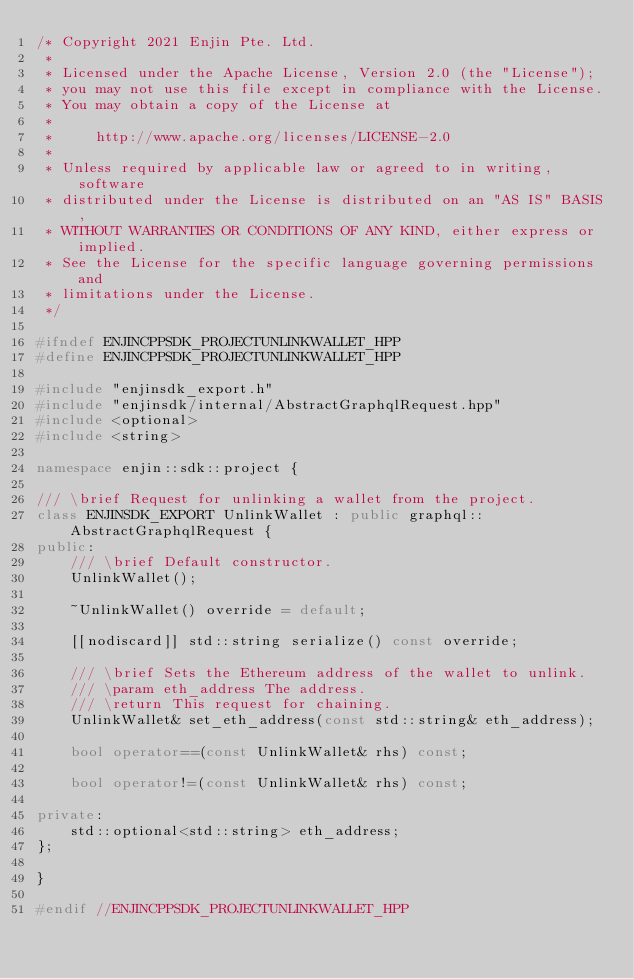Convert code to text. <code><loc_0><loc_0><loc_500><loc_500><_C++_>/* Copyright 2021 Enjin Pte. Ltd.
 *
 * Licensed under the Apache License, Version 2.0 (the "License");
 * you may not use this file except in compliance with the License.
 * You may obtain a copy of the License at
 *
 *     http://www.apache.org/licenses/LICENSE-2.0
 *
 * Unless required by applicable law or agreed to in writing, software
 * distributed under the License is distributed on an "AS IS" BASIS,
 * WITHOUT WARRANTIES OR CONDITIONS OF ANY KIND, either express or implied.
 * See the License for the specific language governing permissions and
 * limitations under the License.
 */

#ifndef ENJINCPPSDK_PROJECTUNLINKWALLET_HPP
#define ENJINCPPSDK_PROJECTUNLINKWALLET_HPP

#include "enjinsdk_export.h"
#include "enjinsdk/internal/AbstractGraphqlRequest.hpp"
#include <optional>
#include <string>

namespace enjin::sdk::project {

/// \brief Request for unlinking a wallet from the project.
class ENJINSDK_EXPORT UnlinkWallet : public graphql::AbstractGraphqlRequest {
public:
    /// \brief Default constructor.
    UnlinkWallet();

    ~UnlinkWallet() override = default;

    [[nodiscard]] std::string serialize() const override;

    /// \brief Sets the Ethereum address of the wallet to unlink.
    /// \param eth_address The address.
    /// \return This request for chaining.
    UnlinkWallet& set_eth_address(const std::string& eth_address);

    bool operator==(const UnlinkWallet& rhs) const;

    bool operator!=(const UnlinkWallet& rhs) const;

private:
    std::optional<std::string> eth_address;
};

}

#endif //ENJINCPPSDK_PROJECTUNLINKWALLET_HPP
</code> 